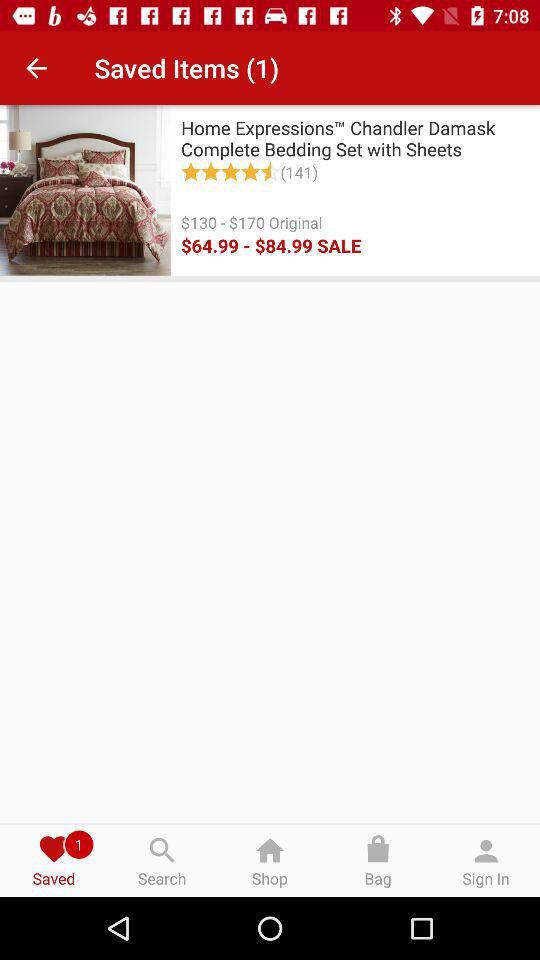Which tab is selected? The selected tab is "Saved". 